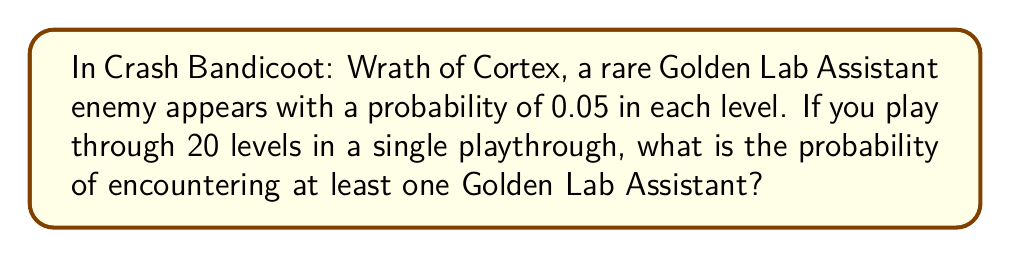Teach me how to tackle this problem. Let's approach this step-by-step:

1) First, let's consider the probability of not encountering a Golden Lab Assistant in a single level:
   $P(\text{no Golden Lab Assistant}) = 1 - 0.05 = 0.95$

2) For 20 levels, the probability of not encountering any Golden Lab Assistant is:
   $P(\text{no Golden Lab Assistant in 20 levels}) = (0.95)^{20}$

3) Therefore, the probability of encountering at least one Golden Lab Assistant is the complement of this probability:
   $P(\text{at least one Golden Lab Assistant}) = 1 - (0.95)^{20}$

4) Let's calculate this:
   $1 - (0.95)^{20} = 1 - 0.3585 = 0.6415$

5) Converting to a percentage:
   $0.6415 \times 100\% = 64.15\%$

Thus, there is approximately a 64.15% chance of encountering at least one Golden Lab Assistant in a 20-level playthrough.
Answer: 64.15% 